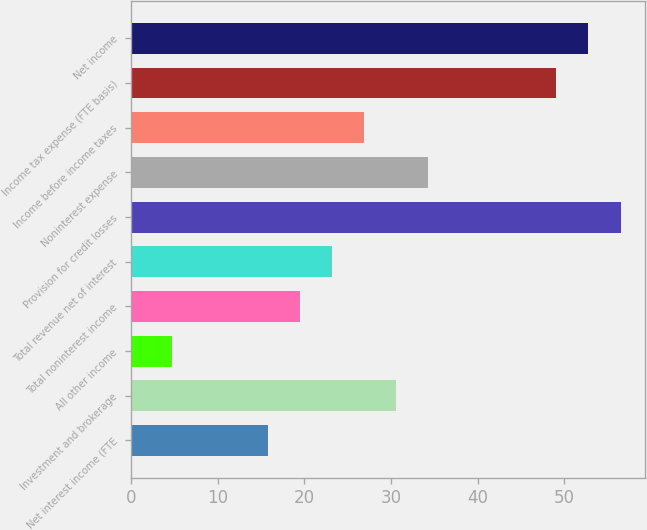Convert chart to OTSL. <chart><loc_0><loc_0><loc_500><loc_500><bar_chart><fcel>Net interest income (FTE<fcel>Investment and brokerage<fcel>All other income<fcel>Total noninterest income<fcel>Total revenue net of interest<fcel>Provision for credit losses<fcel>Noninterest expense<fcel>Income before income taxes<fcel>Income tax expense (FTE basis)<fcel>Net income<nl><fcel>15.8<fcel>30.6<fcel>4.7<fcel>19.5<fcel>23.2<fcel>56.5<fcel>34.3<fcel>26.9<fcel>49.1<fcel>52.8<nl></chart> 